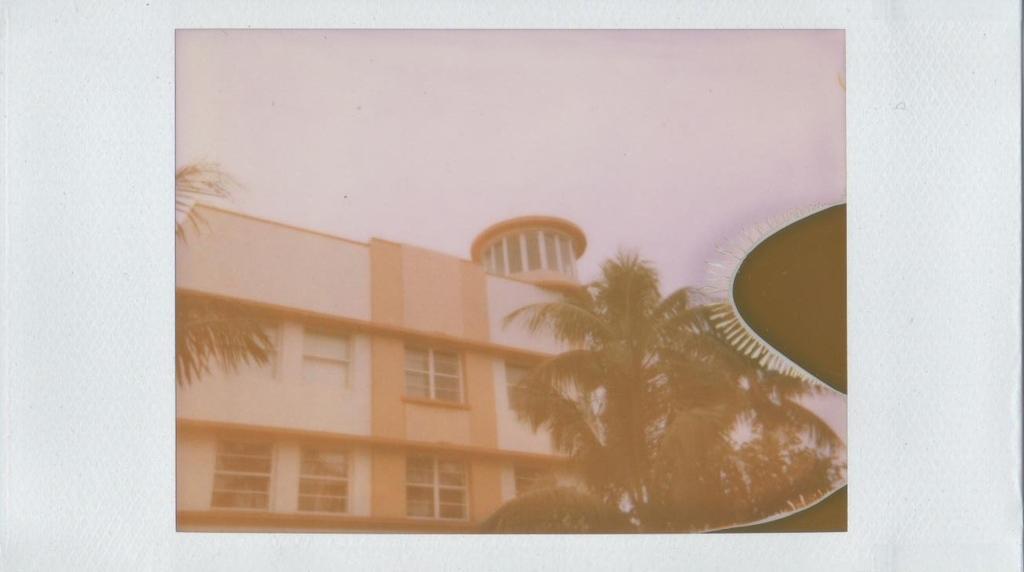In one or two sentences, can you explain what this image depicts? This is an edited image. I can see trees and a building with windows. In the background, there is the sky. 